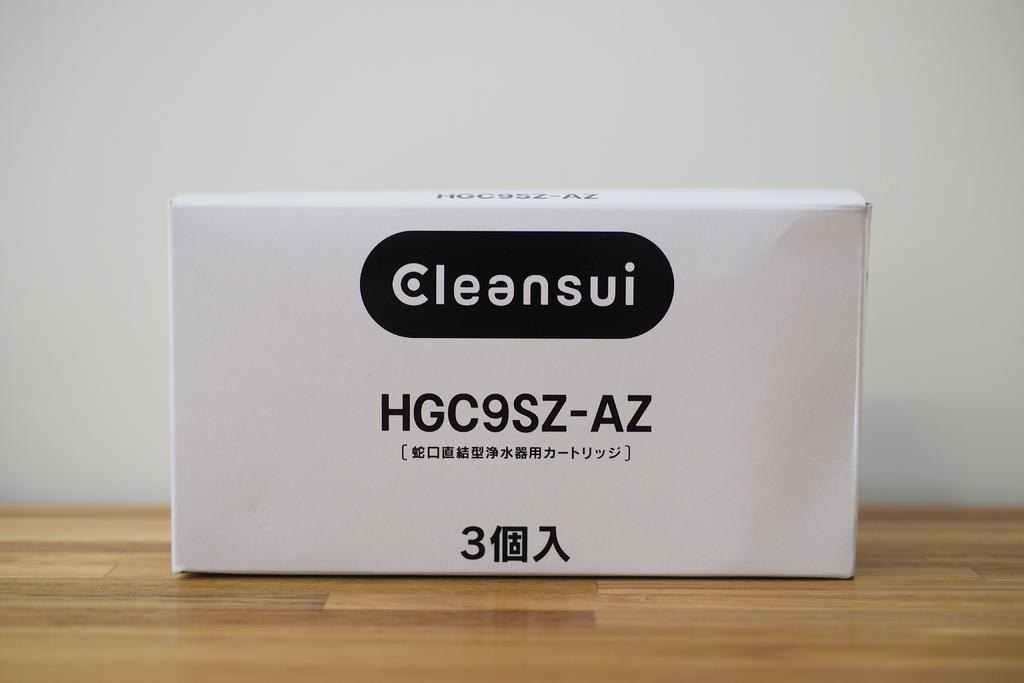<image>
Relay a brief, clear account of the picture shown. a white block with the words Cleansui is sitting on a wooden surface 